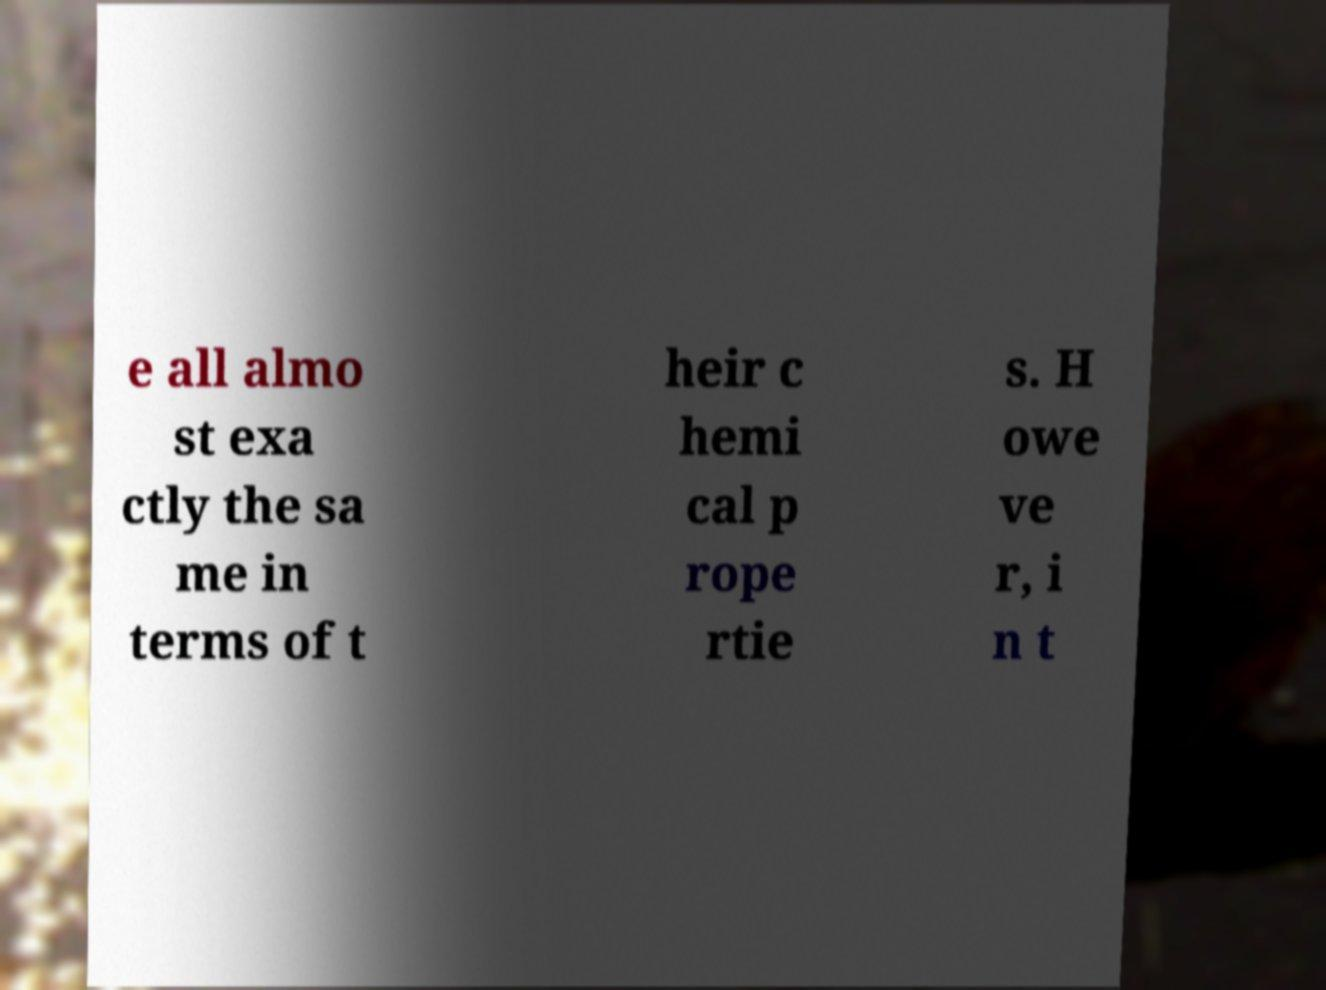Could you assist in decoding the text presented in this image and type it out clearly? e all almo st exa ctly the sa me in terms of t heir c hemi cal p rope rtie s. H owe ve r, i n t 